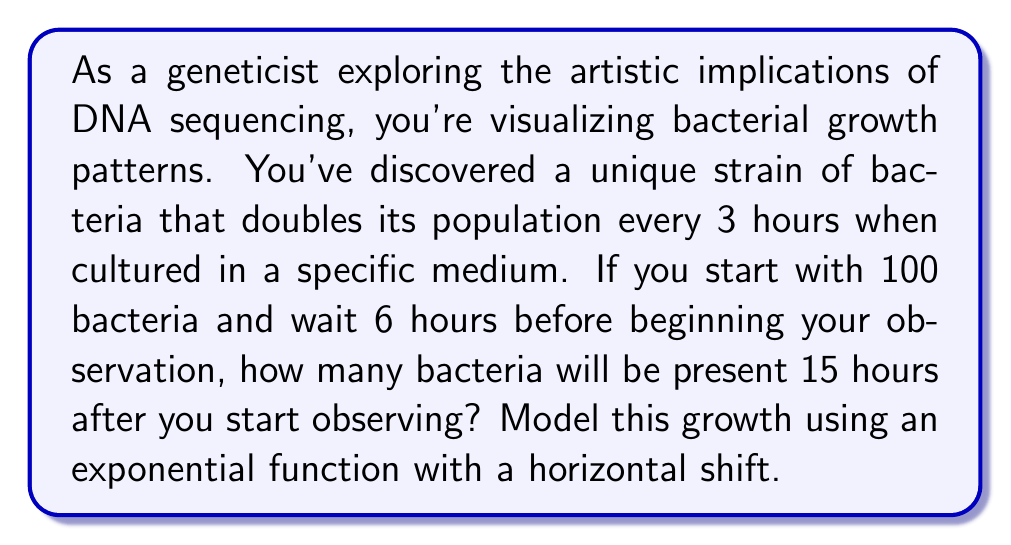Can you solve this math problem? Let's approach this step-by-step:

1) First, we need to set up our exponential growth function. The general form is:

   $$N(t) = N_0 \cdot 2^{t/d}$$

   Where $N(t)$ is the number of bacteria at time $t$, $N_0$ is the initial number of bacteria, and $d$ is the doubling time in hours.

2) We know that:
   - The doubling time $(d)$ is 3 hours
   - The initial number of bacteria $(N_0)$ is 100
   - We wait 6 hours before starting observation

3) To account for the 6-hour wait, we need to calculate how many bacteria are present at the start of observation:

   $$100 \cdot 2^{6/3} = 100 \cdot 2^2 = 100 \cdot 4 = 400$$

   So, $N_0 = 400$ for our observation period.

4) Now, we can set up our shifted exponential function:

   $$N(t) = 400 \cdot 2^{t/3}$$

5) We want to know the number of bacteria 15 hours after we start observing. So, we plug in $t = 15$:

   $$N(15) = 400 \cdot 2^{15/3} = 400 \cdot 2^5 = 400 \cdot 32 = 12,800$$

Thus, 15 hours after starting observation, there will be 12,800 bacteria.
Answer: 12,800 bacteria 